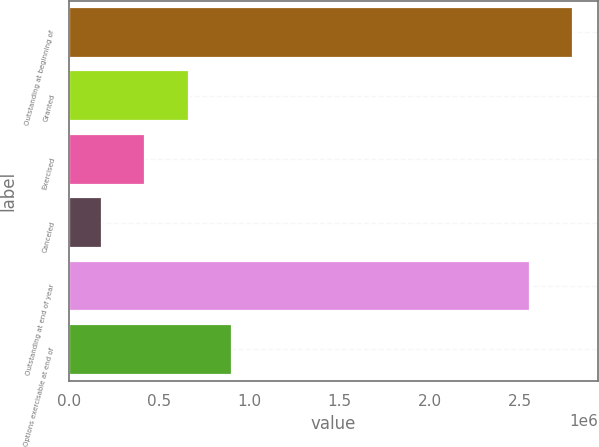<chart> <loc_0><loc_0><loc_500><loc_500><bar_chart><fcel>Outstanding at beginning of<fcel>Granted<fcel>Exercised<fcel>Canceled<fcel>Outstanding at end of year<fcel>Options exercisable at end of<nl><fcel>2.79487e+06<fcel>665066<fcel>423952<fcel>182837<fcel>2.55376e+06<fcel>906180<nl></chart> 